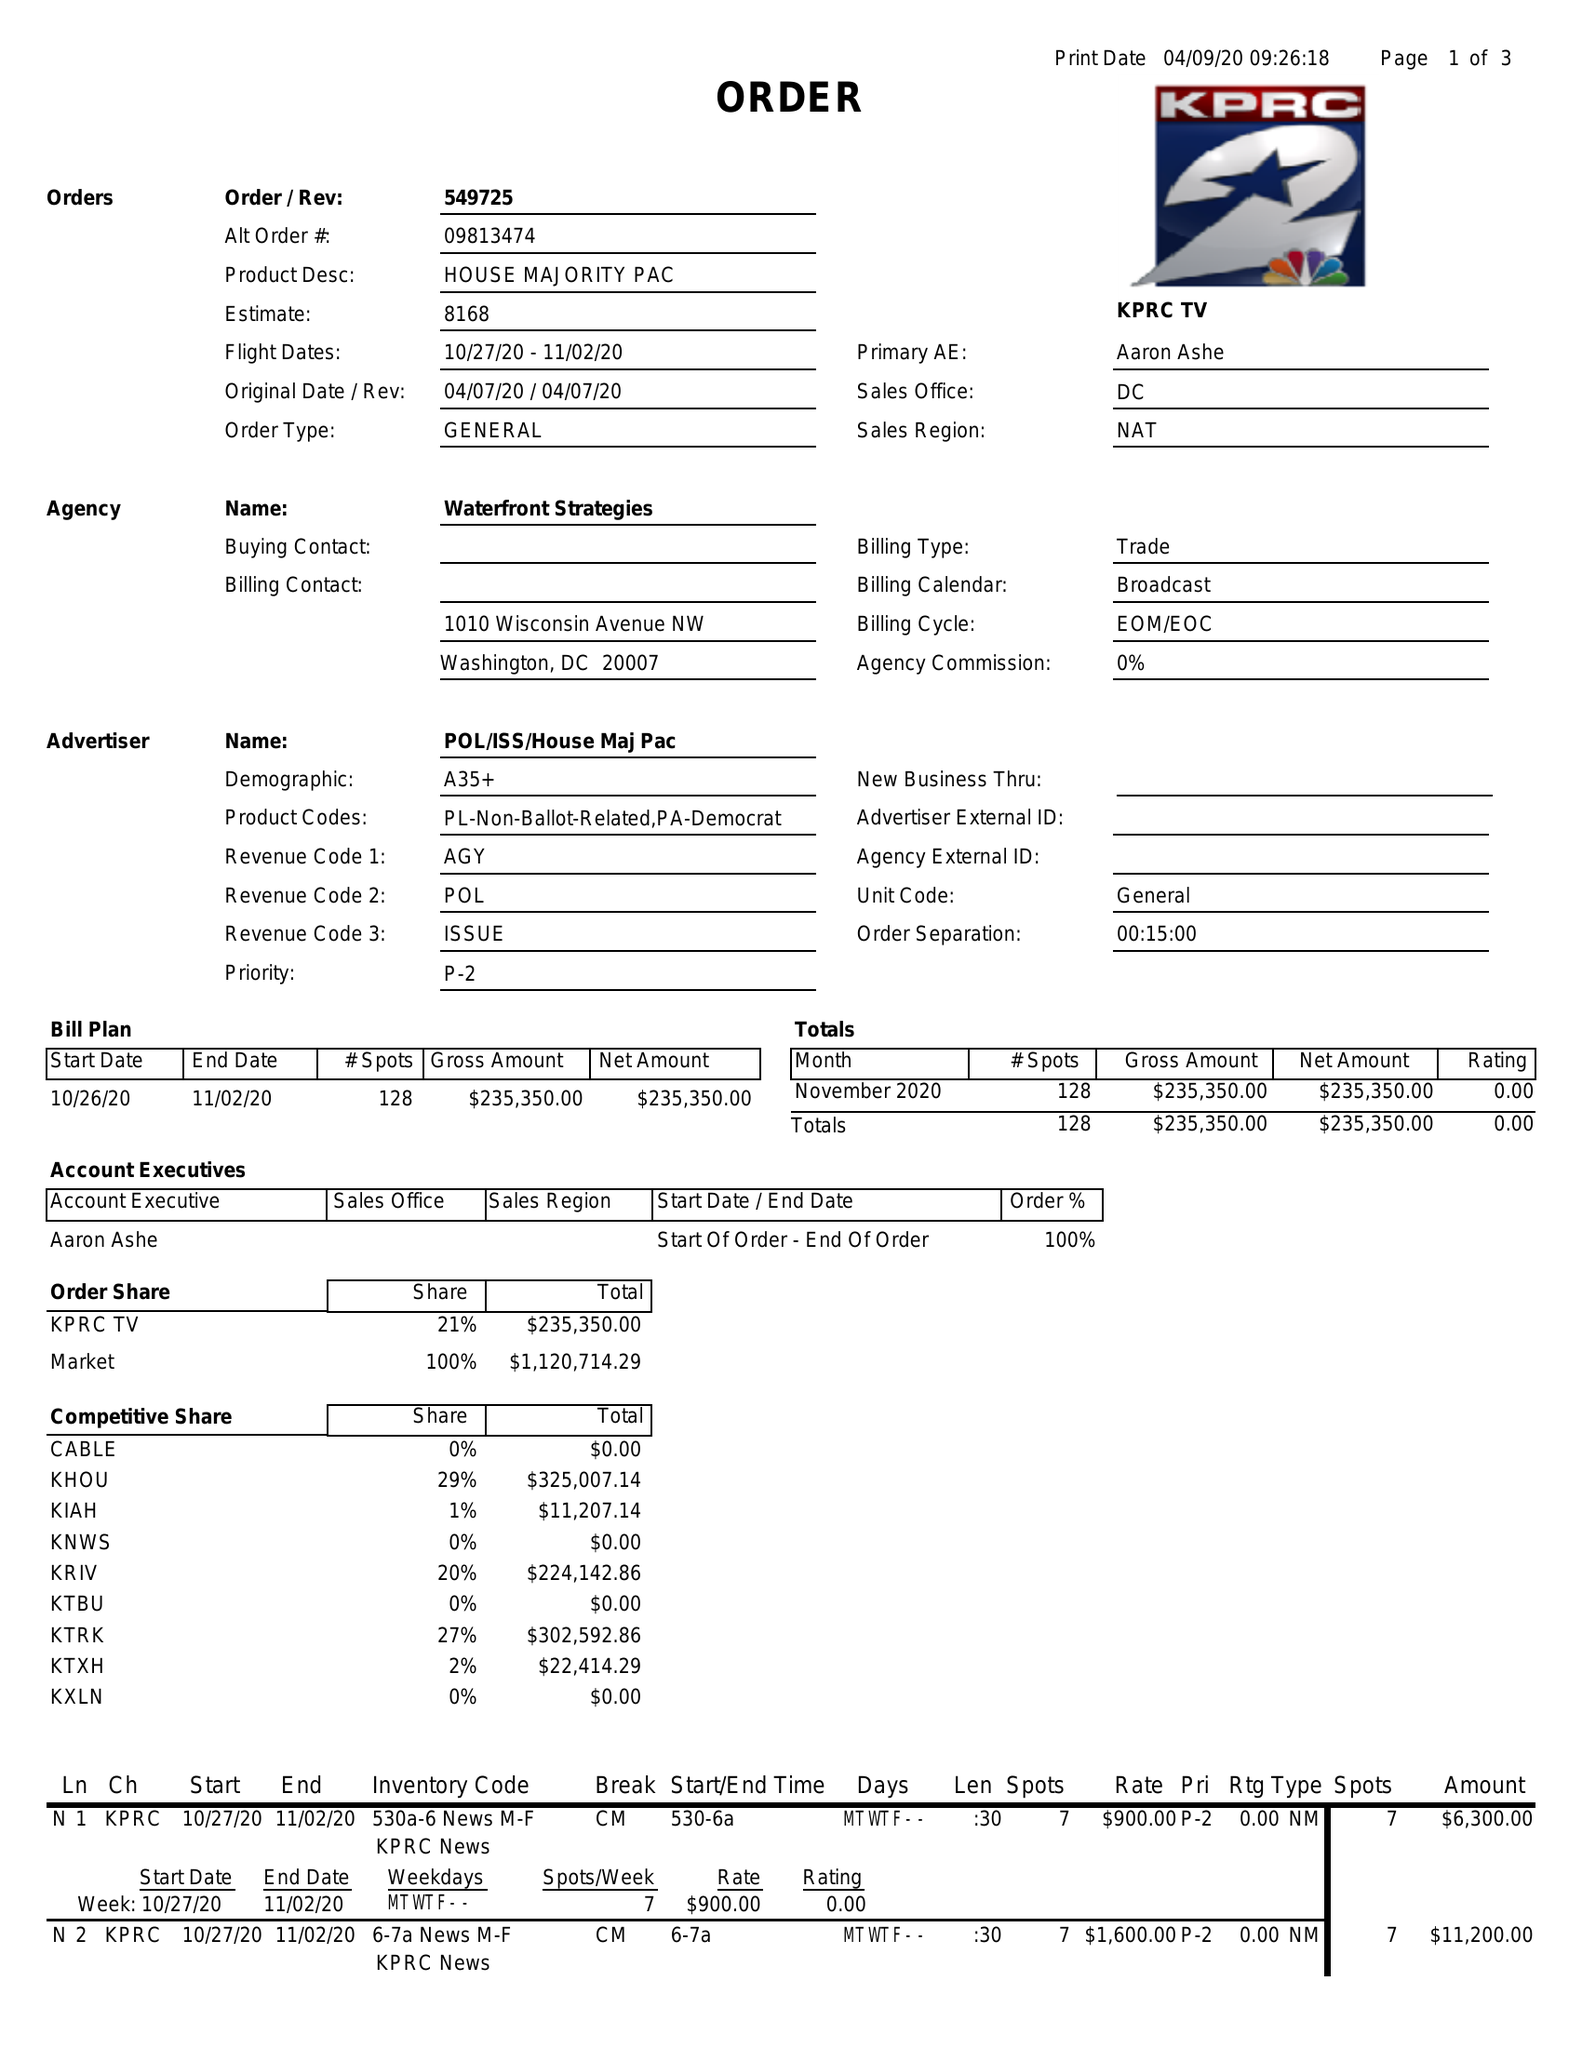What is the value for the flight_to?
Answer the question using a single word or phrase. 11/02/20 